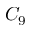Convert formula to latex. <formula><loc_0><loc_0><loc_500><loc_500>C _ { 9 }</formula> 